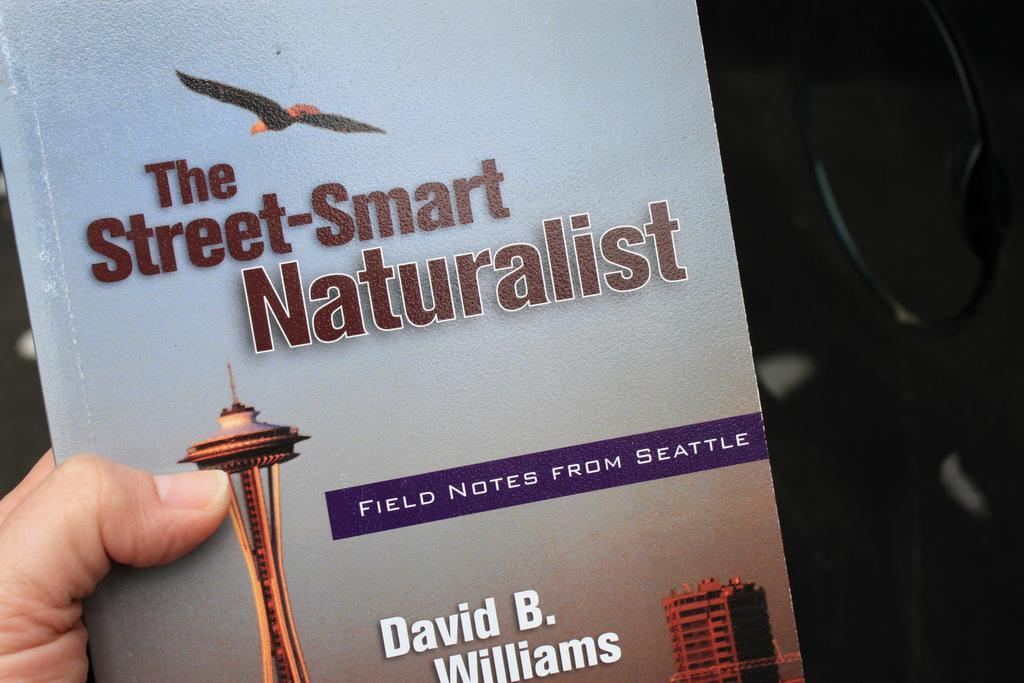<image>
Offer a succinct explanation of the picture presented. a book cover with an image of seattle by David B. Williams 